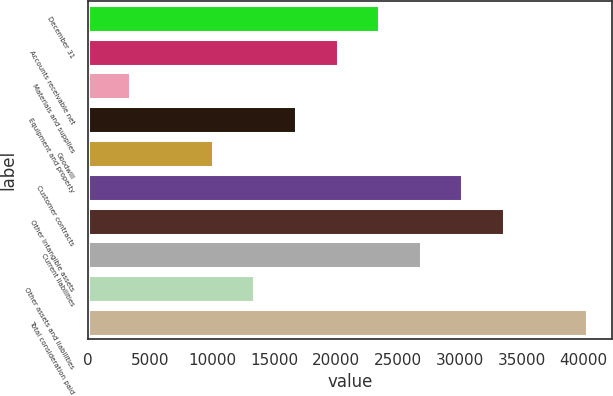Convert chart. <chart><loc_0><loc_0><loc_500><loc_500><bar_chart><fcel>December 31<fcel>Accounts receivable net<fcel>Materials and supplies<fcel>Equipment and property<fcel>Goodwill<fcel>Customer contracts<fcel>Other intangible assets<fcel>Current liabilities<fcel>Other assets and liabilities<fcel>Total consideration paid<nl><fcel>23483.6<fcel>20129.2<fcel>3356.91<fcel>16774.7<fcel>10065.8<fcel>30192.5<fcel>33547<fcel>26838.1<fcel>13420.3<fcel>40255.9<nl></chart> 